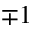<formula> <loc_0><loc_0><loc_500><loc_500>\mp 1</formula> 